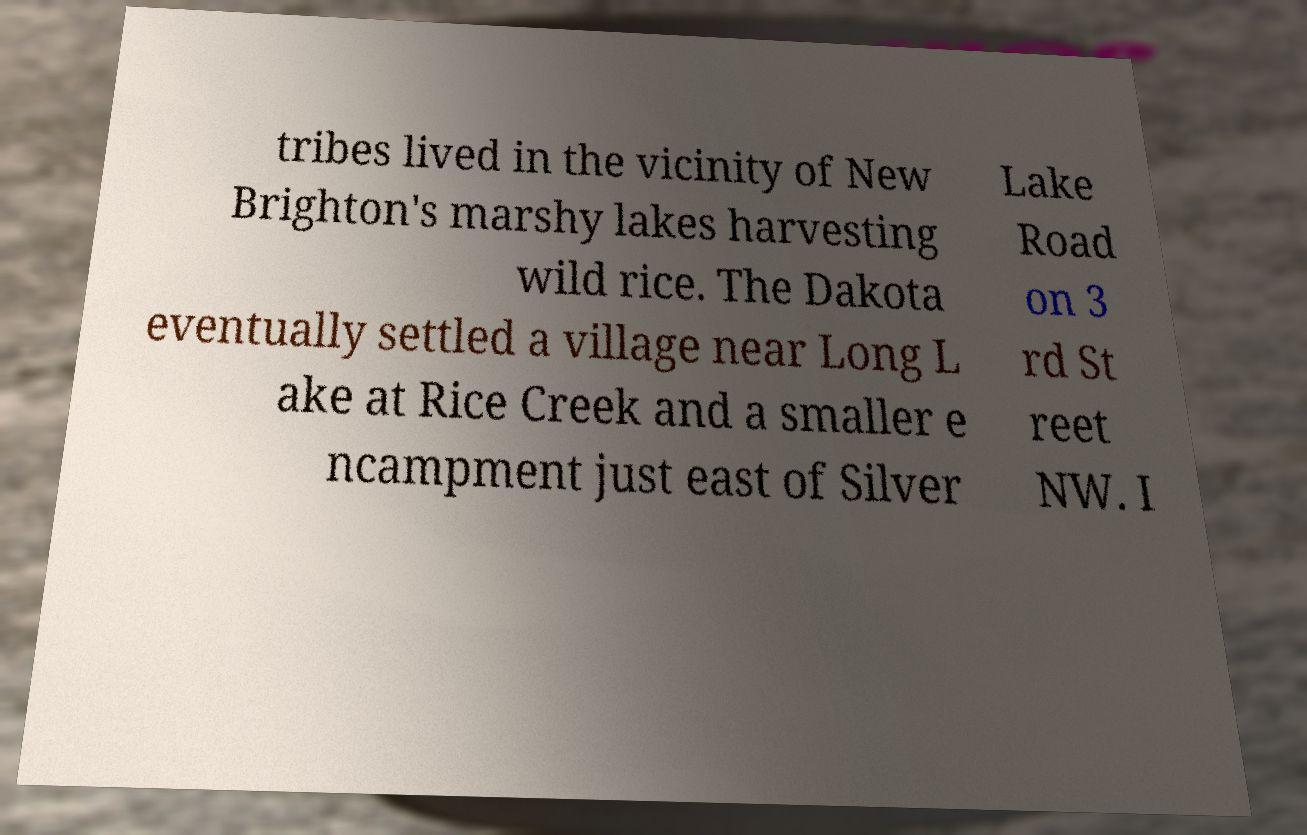Can you read and provide the text displayed in the image?This photo seems to have some interesting text. Can you extract and type it out for me? tribes lived in the vicinity of New Brighton's marshy lakes harvesting wild rice. The Dakota eventually settled a village near Long L ake at Rice Creek and a smaller e ncampment just east of Silver Lake Road on 3 rd St reet NW. I 